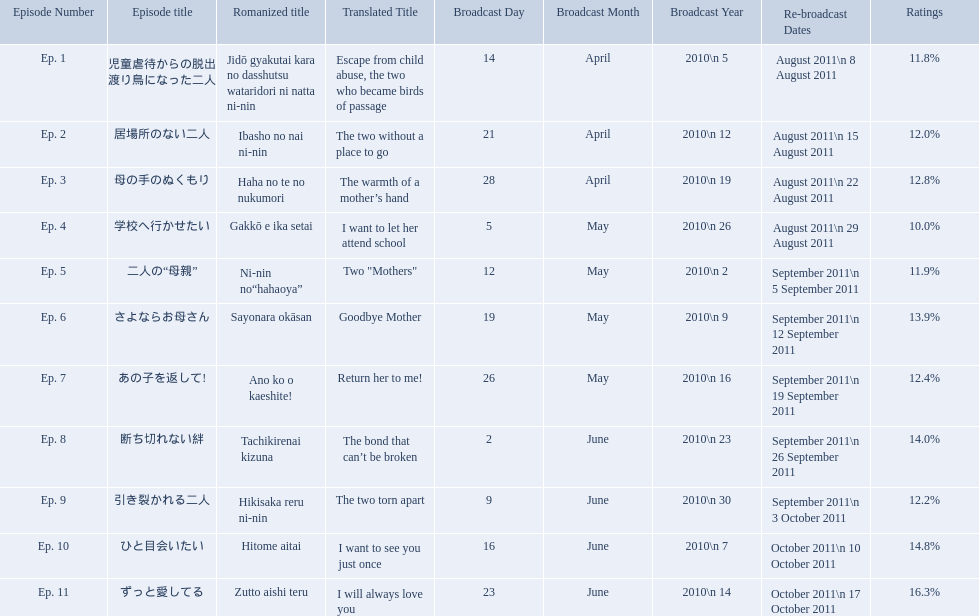What are the episodes of mother? 児童虐待からの脱出 渡り鳥になった二人, 居場所のない二人, 母の手のぬくもり, 学校へ行かせたい, 二人の“母親”, さよならお母さん, あの子を返して!, 断ち切れない絆, 引き裂かれる二人, ひと目会いたい, ずっと愛してる. What is the rating of episode 10? 14.8%. What is the other rating also in the 14 to 15 range? Ep. 8. Which episode had the highest ratings? Ep. 11. Which episode was named haha no te no nukumori? Ep. 3. Besides episode 10 which episode had a 14% rating? Ep. 8. How many total episodes are there? Ep. 1, Ep. 2, Ep. 3, Ep. 4, Ep. 5, Ep. 6, Ep. 7, Ep. 8, Ep. 9, Ep. 10, Ep. 11. Of those episodes, which one has the title of the bond that can't be broken? Ep. 8. What was the ratings percentage for that episode? 14.0%. What were all the episode titles for the show mother? 児童虐待からの脱出 渡り鳥になった二人, 居場所のない二人, 母の手のぬくもり, 学校へ行かせたい, 二人の“母親”, さよならお母さん, あの子を返して!, 断ち切れない絆, 引き裂かれる二人, ひと目会いたい, ずっと愛してる. What were all the translated episode titles for the show mother? Escape from child abuse, the two who became birds of passage, The two without a place to go, The warmth of a mother’s hand, I want to let her attend school, Two "Mothers", Goodbye Mother, Return her to me!, The bond that can’t be broken, The two torn apart, I want to see you just once, I will always love you. Which episode was translated to i want to let her attend school? Ep. 4. Could you help me parse every detail presented in this table? {'header': ['Episode Number', 'Episode title', 'Romanized title', 'Translated Title', 'Broadcast Day', 'Broadcast Month', 'Broadcast Year', 'Re-broadcast Dates', 'Ratings'], 'rows': [['Ep. 1', '児童虐待からの脱出 渡り鳥になった二人', 'Jidō gyakutai kara no dasshutsu wataridori ni natta ni-nin', 'Escape from child abuse, the two who became birds of passage', '14', 'April', '2010\\n 5', 'August 2011\\n 8 August 2011', '11.8%'], ['Ep. 2', '居場所のない二人', 'Ibasho no nai ni-nin', 'The two without a place to go', '21', 'April', '2010\\n 12', 'August 2011\\n 15 August 2011', '12.0%'], ['Ep. 3', '母の手のぬくもり', 'Haha no te no nukumori', 'The warmth of a mother’s hand', '28', 'April', '2010\\n 19', 'August 2011\\n 22 August 2011', '12.8%'], ['Ep. 4', '学校へ行かせたい', 'Gakkō e ika setai', 'I want to let her attend school', '5', 'May', '2010\\n 26', 'August 2011\\n 29 August 2011', '10.0%'], ['Ep. 5', '二人の“母親”', 'Ni-nin no“hahaoya”', 'Two "Mothers"', '12', 'May', '2010\\n 2', 'September 2011\\n 5 September 2011', '11.9%'], ['Ep. 6', 'さよならお母さん', 'Sayonara okāsan', 'Goodbye Mother', '19', 'May', '2010\\n 9', 'September 2011\\n 12 September 2011', '13.9%'], ['Ep. 7', 'あの子を返して!', 'Ano ko o kaeshite!', 'Return her to me!', '26', 'May', '2010\\n 16', 'September 2011\\n 19 September 2011', '12.4%'], ['Ep. 8', '断ち切れない絆', 'Tachikirenai kizuna', 'The bond that can’t be broken', '2', 'June', '2010\\n 23', 'September 2011\\n 26 September 2011', '14.0%'], ['Ep. 9', '引き裂かれる二人', 'Hikisaka reru ni-nin', 'The two torn apart', '9', 'June', '2010\\n 30', 'September 2011\\n 3 October 2011', '12.2%'], ['Ep. 10', 'ひと目会いたい', 'Hitome aitai', 'I want to see you just once', '16', 'June', '2010\\n 7', 'October 2011\\n 10 October 2011', '14.8%'], ['Ep. 11', 'ずっと愛してる', 'Zutto aishi teru', 'I will always love you', '23', 'June', '2010\\n 14', 'October 2011\\n 17 October 2011', '16.3%']]} What are the rating percentages for each episode? 11.8%, 12.0%, 12.8%, 10.0%, 11.9%, 13.9%, 12.4%, 14.0%, 12.2%, 14.8%, 16.3%. What is the highest rating an episode got? 16.3%. What episode got a rating of 16.3%? ずっと愛してる. 